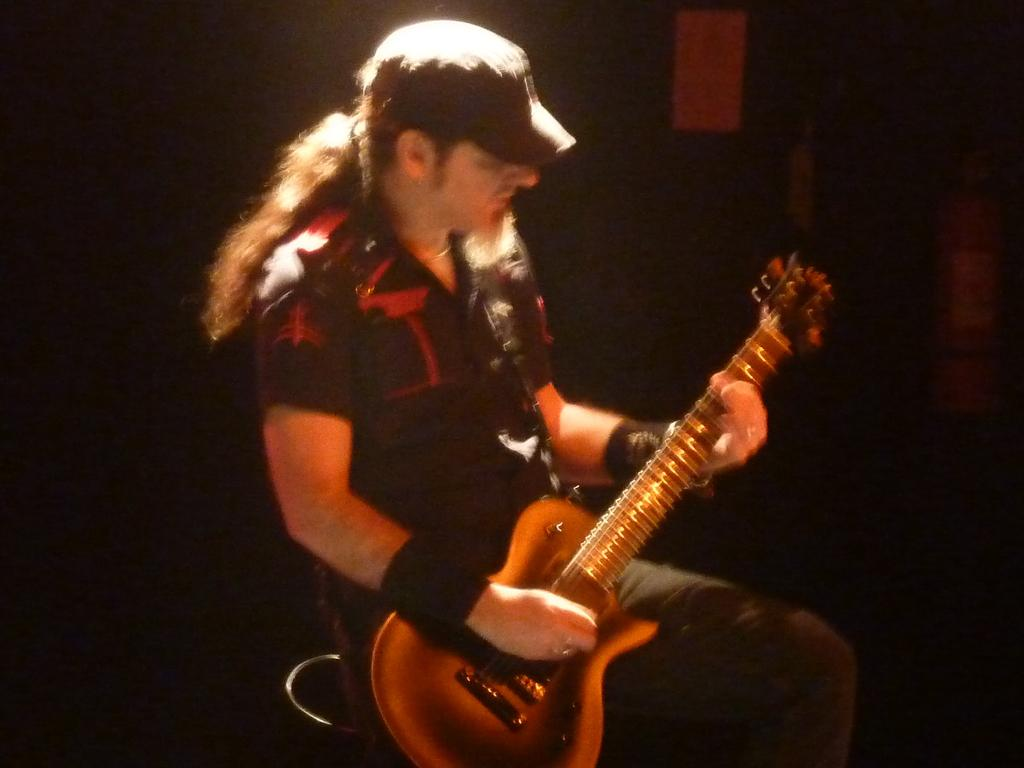What is the main subject of the image? The main subject of the image is a man. What is the man holding in the image? The man is holding a guitar. Where is the man positioned in the image? The man is in the middle of the image. What can be observed about the background of the image? The background of the image is dark. Can you tell me how many girls are standing next to the man in the image? There are no girls present in the image; it only features a man holding a guitar. What type of giants can be seen in the background of the image? There are no giants present in the image; the background is dark. 